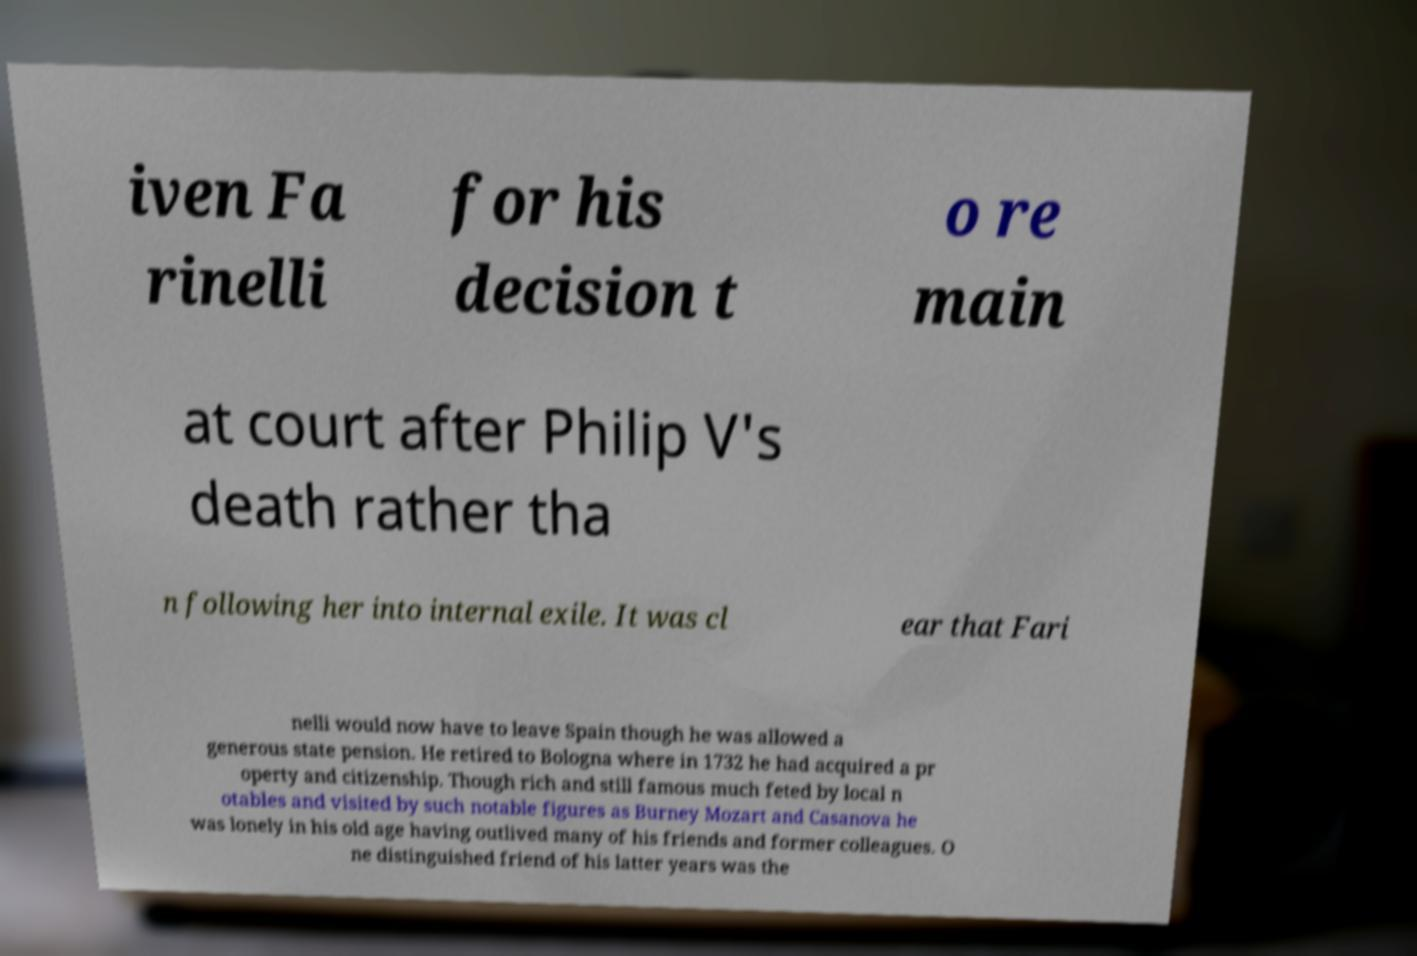Can you accurately transcribe the text from the provided image for me? iven Fa rinelli for his decision t o re main at court after Philip V's death rather tha n following her into internal exile. It was cl ear that Fari nelli would now have to leave Spain though he was allowed a generous state pension. He retired to Bologna where in 1732 he had acquired a pr operty and citizenship. Though rich and still famous much feted by local n otables and visited by such notable figures as Burney Mozart and Casanova he was lonely in his old age having outlived many of his friends and former colleagues. O ne distinguished friend of his latter years was the 